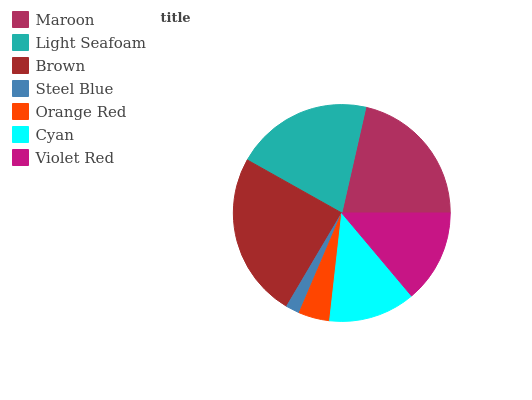Is Steel Blue the minimum?
Answer yes or no. Yes. Is Brown the maximum?
Answer yes or no. Yes. Is Light Seafoam the minimum?
Answer yes or no. No. Is Light Seafoam the maximum?
Answer yes or no. No. Is Maroon greater than Light Seafoam?
Answer yes or no. Yes. Is Light Seafoam less than Maroon?
Answer yes or no. Yes. Is Light Seafoam greater than Maroon?
Answer yes or no. No. Is Maroon less than Light Seafoam?
Answer yes or no. No. Is Violet Red the high median?
Answer yes or no. Yes. Is Violet Red the low median?
Answer yes or no. Yes. Is Orange Red the high median?
Answer yes or no. No. Is Orange Red the low median?
Answer yes or no. No. 